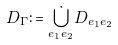Convert formula to latex. <formula><loc_0><loc_0><loc_500><loc_500>D _ { \Gamma } \colon = \dot { \bigcup _ { e _ { 1 } e _ { 2 } } } D _ { e _ { 1 } e _ { 2 } }</formula> 